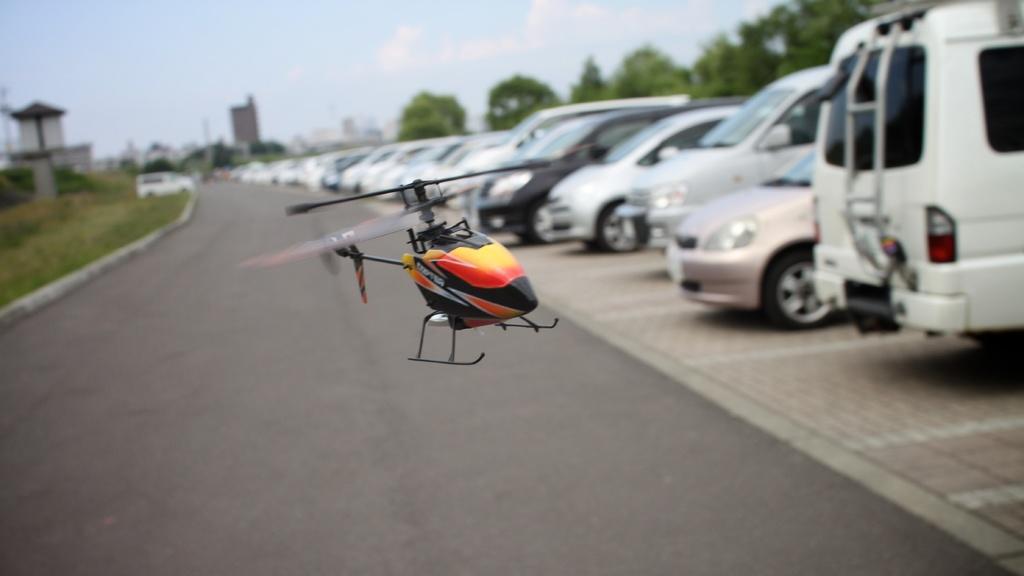How would you summarize this image in a sentence or two? In this image in the center there is the helicopter rotor and in the background there are cars, trees, buildings and on the left side there is grass on the ground. 